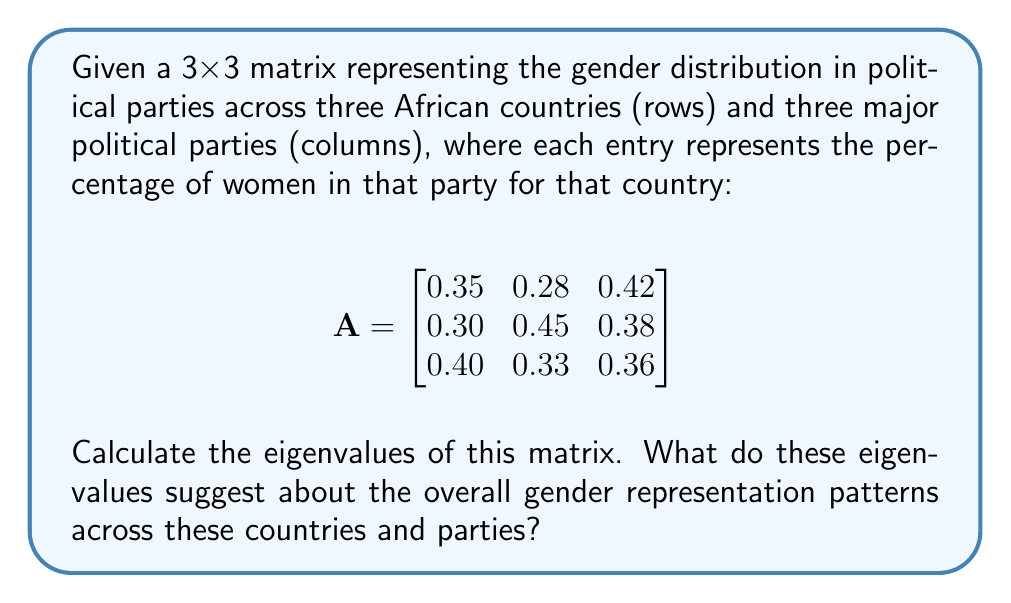Teach me how to tackle this problem. To find the eigenvalues of matrix A, we need to solve the characteristic equation:

$det(A - \lambda I) = 0$

Where $I$ is the 3x3 identity matrix and $\lambda$ represents the eigenvalues.

Step 1: Set up the characteristic equation:

$$det\begin{pmatrix}
0.35 - \lambda & 0.28 & 0.42 \\
0.30 & 0.45 - \lambda & 0.38 \\
0.40 & 0.33 & 0.36 - \lambda
\end{pmatrix} = 0$$

Step 2: Expand the determinant:

$(0.35 - \lambda)[(0.45 - \lambda)(0.36 - \lambda) - 0.38 \cdot 0.33] - 0.28[0.30(0.36 - \lambda) - 0.40 \cdot 0.38] + 0.42[0.30 \cdot 0.33 - 0.40(0.45 - \lambda)] = 0$

Step 3: Simplify and collect terms:

$-\lambda^3 + 1.16\lambda^2 - 0.3439\lambda + 0.0255 = 0$

Step 4: Solve this cubic equation. The solutions are the eigenvalues.

Using a numerical method or a cubic equation solver, we find the eigenvalues:

$\lambda_1 \approx 1.0054$
$\lambda_2 \approx 0.1134$
$\lambda_3 \approx 0.0412$

Interpretation: The largest eigenvalue (1.0054) being close to 1 suggests that there is a dominant pattern of gender distribution across the countries and parties. The smaller eigenvalues indicate less significant patterns or variations in the data.
Answer: The eigenvalues of the matrix are approximately:
$\lambda_1 \approx 1.0054$
$\lambda_2 \approx 0.1134$
$\lambda_3 \approx 0.0412$ 